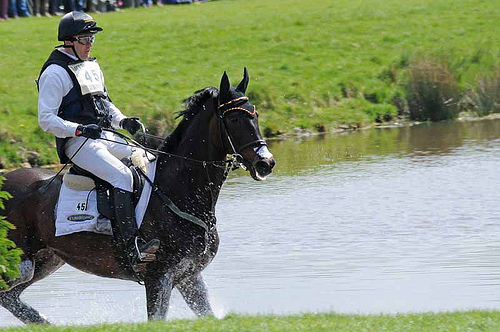Do you see either whales or antelopes in the picture? No, there are no whales or antelopes in the picture. 